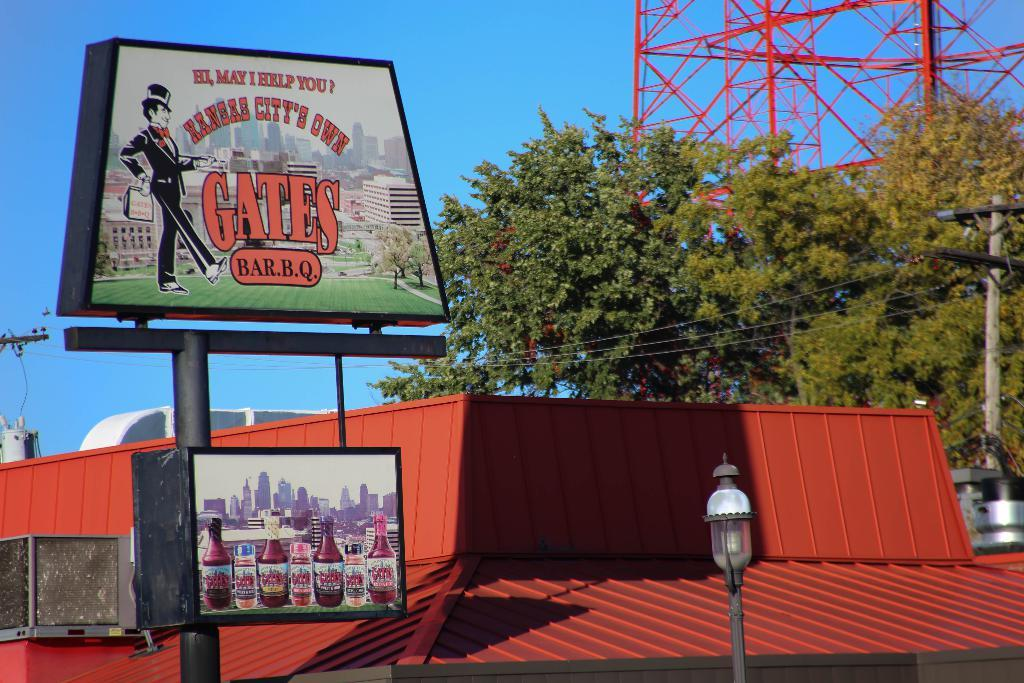<image>
Offer a succinct explanation of the picture presented. A sign for the restaurant Gates BARQ in Kansas City. 